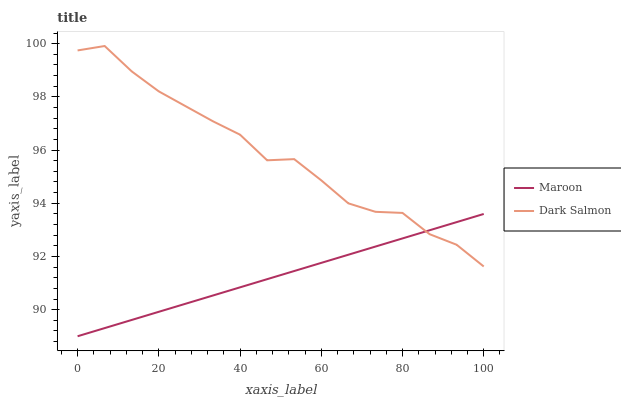Does Maroon have the maximum area under the curve?
Answer yes or no. No. Is Maroon the roughest?
Answer yes or no. No. Does Maroon have the highest value?
Answer yes or no. No. 